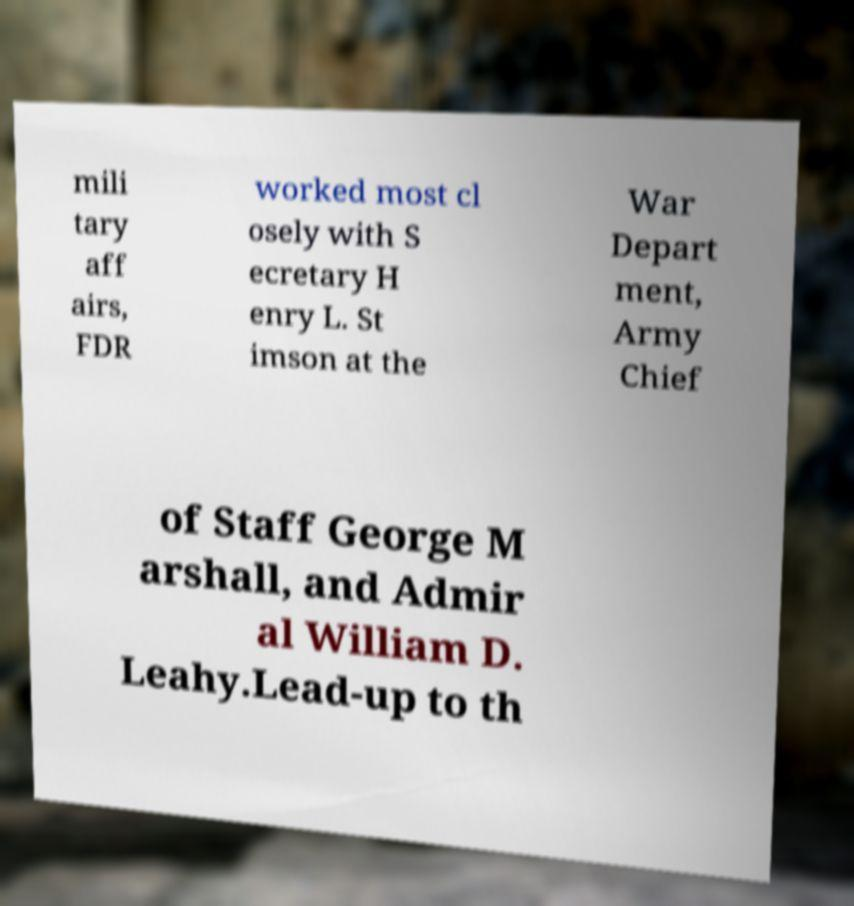I need the written content from this picture converted into text. Can you do that? mili tary aff airs, FDR worked most cl osely with S ecretary H enry L. St imson at the War Depart ment, Army Chief of Staff George M arshall, and Admir al William D. Leahy.Lead-up to th 